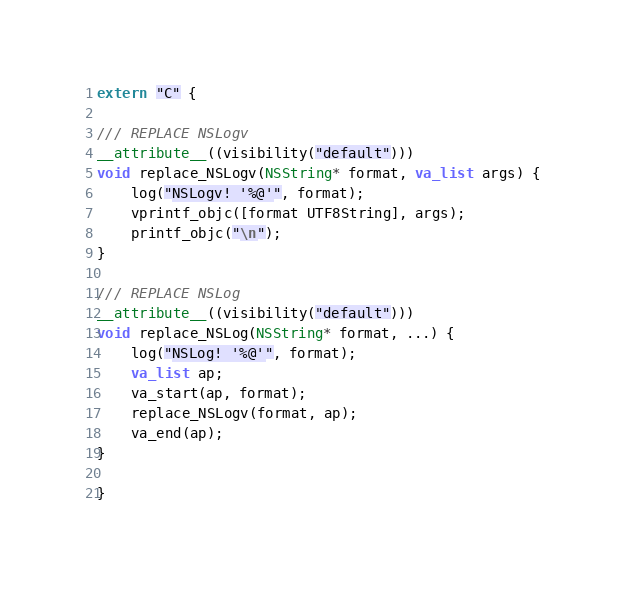<code> <loc_0><loc_0><loc_500><loc_500><_ObjectiveC_>extern "C" {

/// REPLACE NSLogv
__attribute__((visibility("default")))
void replace_NSLogv(NSString* format, va_list args) {
    log("NSLogv! '%@'", format);
    vprintf_objc([format UTF8String], args);
    printf_objc("\n");
}

/// REPLACE NSLog
__attribute__((visibility("default")))
void replace_NSLog(NSString* format, ...) {
    log("NSLog! '%@'", format);
    va_list ap;
    va_start(ap, format);
    replace_NSLogv(format, ap);
    va_end(ap);
}

}
</code> 